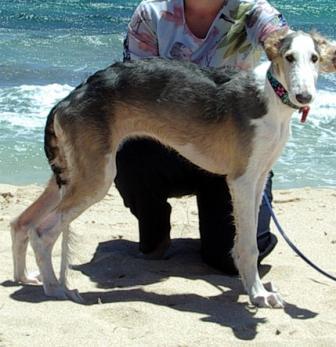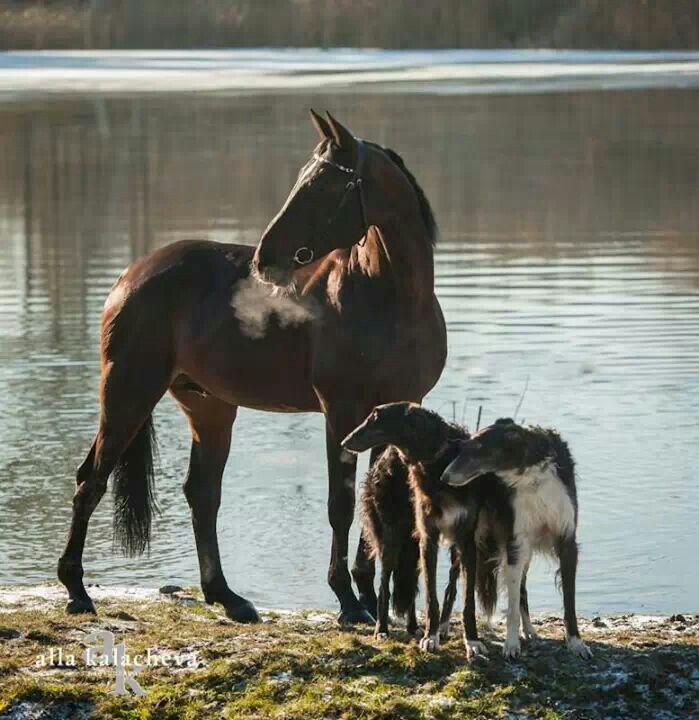The first image is the image on the left, the second image is the image on the right. Evaluate the accuracy of this statement regarding the images: "The combined images include a person near a dog and a dog next to a horse.". Is it true? Answer yes or no. Yes. The first image is the image on the left, the second image is the image on the right. Examine the images to the left and right. Is the description "There is a horse and two dogs staring in the same direction" accurate? Answer yes or no. Yes. 